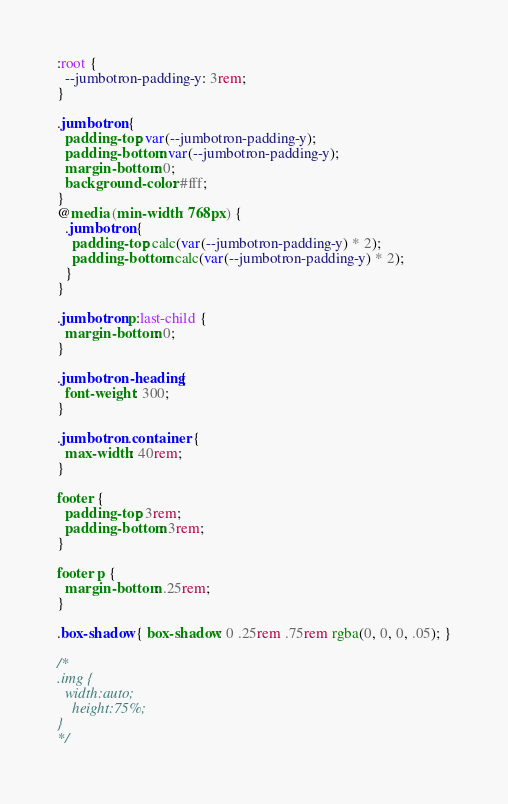<code> <loc_0><loc_0><loc_500><loc_500><_CSS_>:root {
  --jumbotron-padding-y: 3rem;
}

.jumbotron {
  padding-top: var(--jumbotron-padding-y);
  padding-bottom: var(--jumbotron-padding-y);
  margin-bottom: 0;
  background-color: #fff;
}
@media (min-width: 768px) {
  .jumbotron {
    padding-top: calc(var(--jumbotron-padding-y) * 2);
    padding-bottom: calc(var(--jumbotron-padding-y) * 2);
  }
}

.jumbotron p:last-child {
  margin-bottom: 0;
}

.jumbotron-heading {
  font-weight: 300;
}

.jumbotron .container {
  max-width: 40rem;
}

footer {
  padding-top: 3rem;
  padding-bottom: 3rem;
}

footer p {
  margin-bottom: .25rem;
}

.box-shadow { box-shadow: 0 .25rem .75rem rgba(0, 0, 0, .05); }

/*
.img {
  width:auto;
	height:75%;
}
*/
</code> 